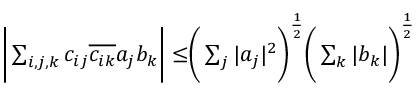<formula> <loc_0><loc_0><loc_500><loc_500>\begin{array} { r } { \left | \sum _ { i , j , k } c _ { i j } \overline { { c _ { i k } } } a _ { j } b _ { k } \right | \leq \left ( \sum _ { j } | a _ { j } | ^ { 2 } \right ) ^ { \frac { 1 } { 2 } } \left ( \sum _ { k } | b _ { k } | \right ) ^ { \frac { 1 } { 2 } } } \end{array}</formula> 